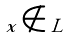Convert formula to latex. <formula><loc_0><loc_0><loc_500><loc_500>x \notin L</formula> 